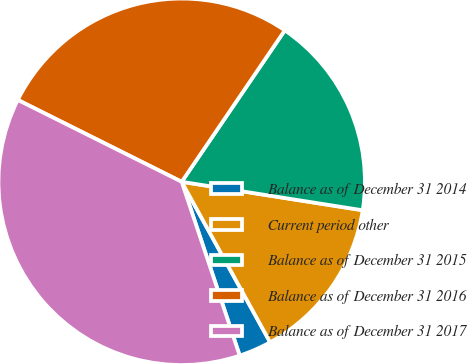Convert chart to OTSL. <chart><loc_0><loc_0><loc_500><loc_500><pie_chart><fcel>Balance as of December 31 2014<fcel>Current period other<fcel>Balance as of December 31 2015<fcel>Balance as of December 31 2016<fcel>Balance as of December 31 2017<nl><fcel>2.89%<fcel>14.5%<fcel>17.97%<fcel>27.14%<fcel>37.5%<nl></chart> 